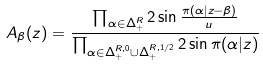<formula> <loc_0><loc_0><loc_500><loc_500>A _ { \beta } ( z ) = \frac { \prod _ { \alpha \in \Delta ^ { R } _ { + } } 2 \sin { \frac { \pi ( \alpha | z - \beta ) } { u } } } { \prod _ { \alpha \in \Delta ^ { R , 0 } _ { + } \cup \Delta ^ { R , 1 / 2 } _ { + } } 2 \sin \pi ( \alpha | z ) }</formula> 